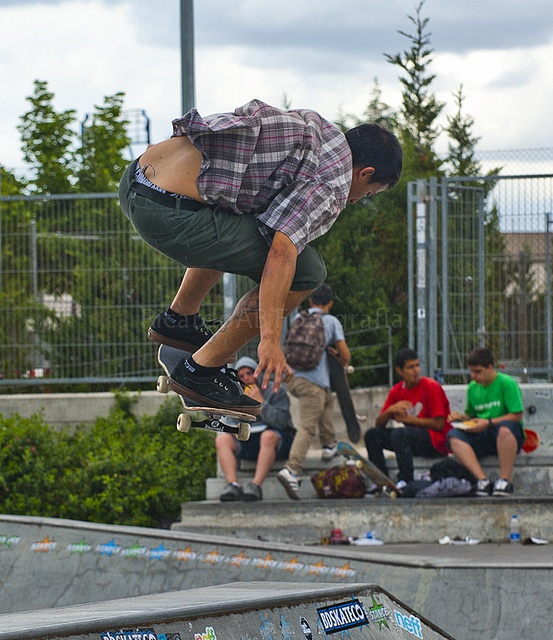Describe the objects in this image and their specific colors. I can see people in lightblue, black, gray, brown, and darkgray tones, people in lightblue, black, maroon, brown, and gray tones, people in lightblue, black, brown, gray, and darkgreen tones, people in lightblue, gray, and black tones, and people in lightblue, black, gray, brown, and salmon tones in this image. 